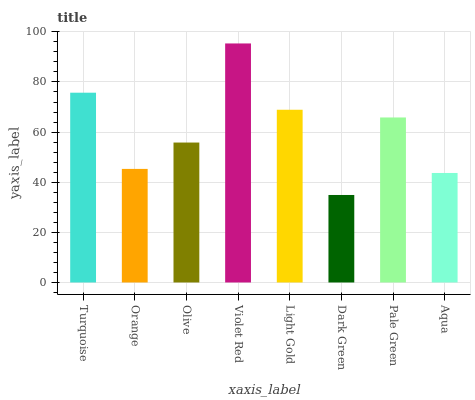Is Dark Green the minimum?
Answer yes or no. Yes. Is Violet Red the maximum?
Answer yes or no. Yes. Is Orange the minimum?
Answer yes or no. No. Is Orange the maximum?
Answer yes or no. No. Is Turquoise greater than Orange?
Answer yes or no. Yes. Is Orange less than Turquoise?
Answer yes or no. Yes. Is Orange greater than Turquoise?
Answer yes or no. No. Is Turquoise less than Orange?
Answer yes or no. No. Is Pale Green the high median?
Answer yes or no. Yes. Is Olive the low median?
Answer yes or no. Yes. Is Violet Red the high median?
Answer yes or no. No. Is Pale Green the low median?
Answer yes or no. No. 